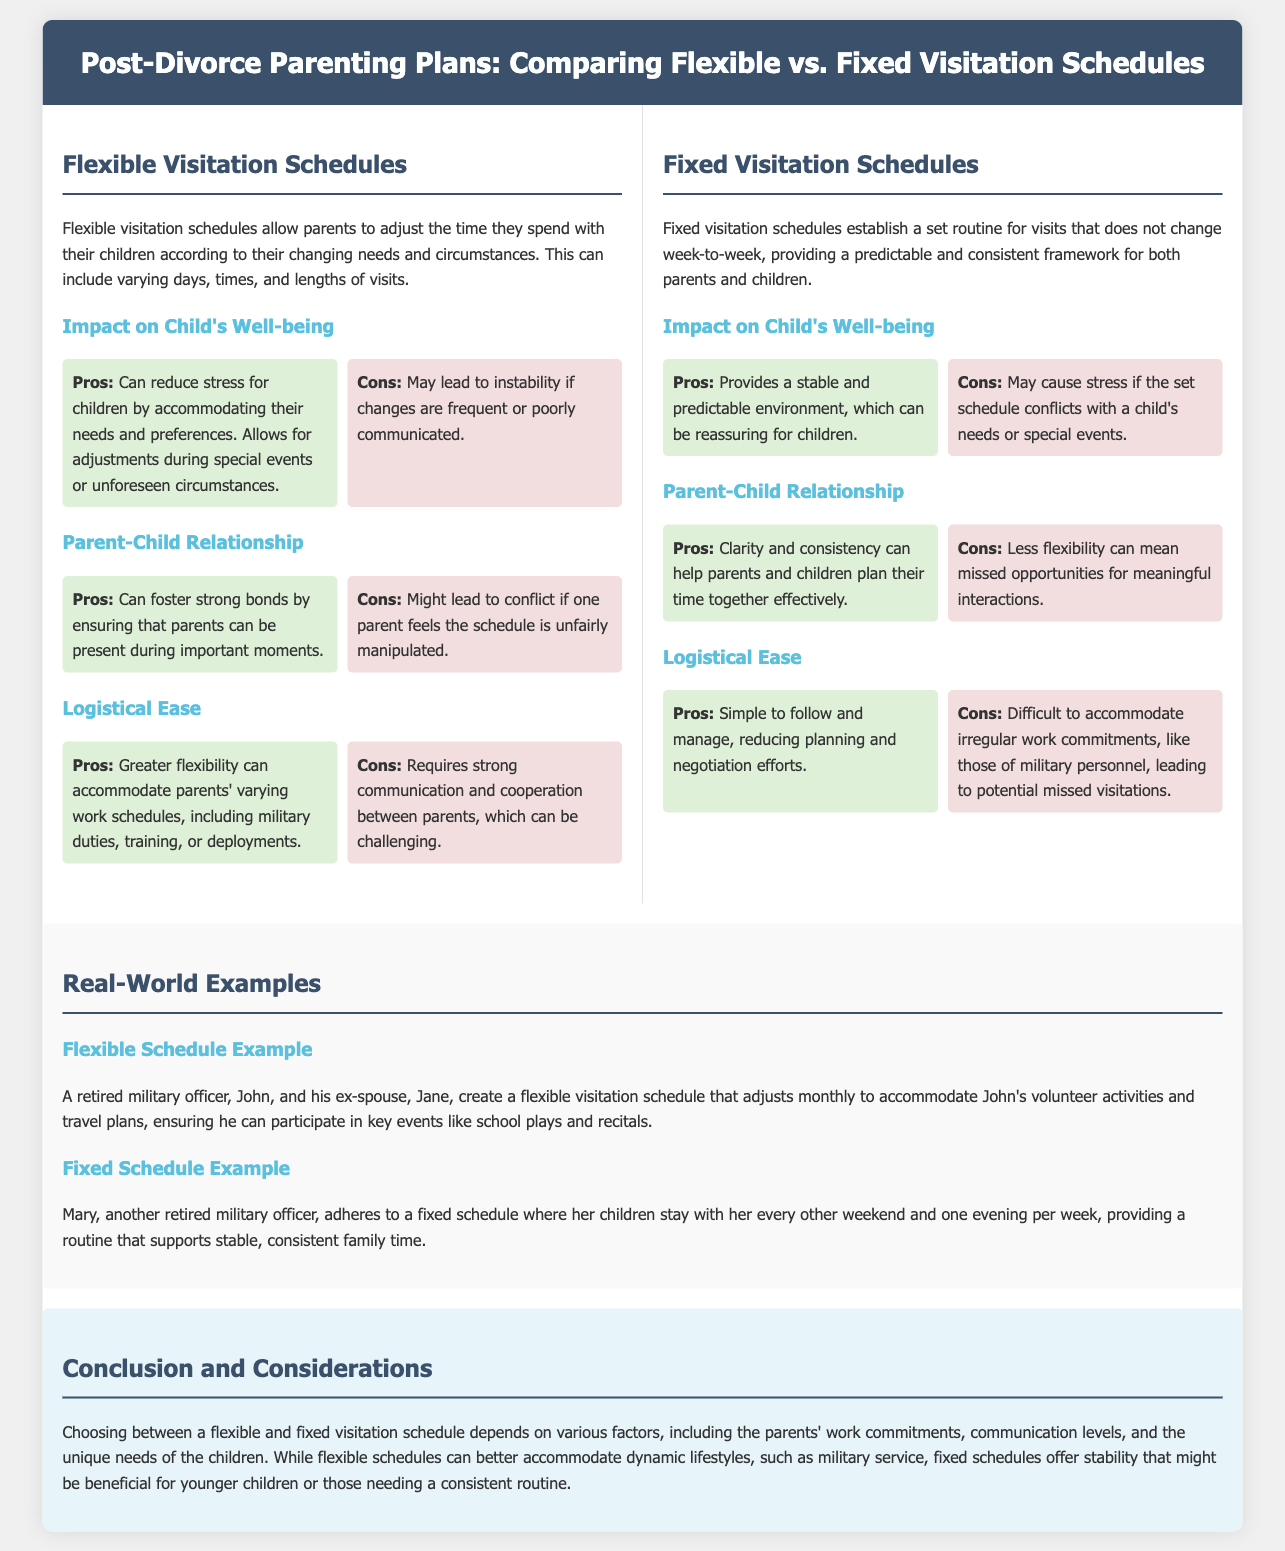What is a flexible visitation schedule? A flexible visitation schedule allows parents to adjust the time they spend with their children according to their changing needs and circumstances.
Answer: A flexible visitation schedule What is the pro of fixed visitation schedules regarding child's well-being? The pro of fixed visitation schedules regarding child's well-being is that it provides a stable and predictable environment, which can be reassuring for children.
Answer: Stable and predictable environment What might cause stress in a fixed visitation schedule? A fixed visitation schedule may cause stress if the set schedule conflicts with a child's needs or special events.
Answer: Conflicts with child's needs What is a disadvantage of flexible visitation schedules for parent-child relationships? A disadvantage of flexible visitation schedules for parent-child relationships is that it might lead to conflict if one parent feels the schedule is unfairly manipulated.
Answer: Conflict How does a flexible schedule accommodate military commitments? Greater flexibility can accommodate parents' varying work schedules, including military duties, training, or deployments.
Answer: Greater flexibility What example was given for a fixed schedule? Mary, another retired military officer, adheres to a fixed schedule where her children stay with her every other weekend and one evening per week.
Answer: Mary What is emphasized in the conclusion regarding schedule choice? Choosing between a flexible and fixed visitation schedule depends on various factors, including the parents' work commitments, communication levels, and the unique needs of the children.
Answer: Various factors How does the document categorize visitation schedules? The document categorizes visitation schedules into flexible and fixed visitation schedules.
Answer: Flexible and fixed What does a fixed schedule offer according to the conclusion? A fixed schedule offers stability that might be beneficial for younger children or those needing a consistent routine.
Answer: Stability 